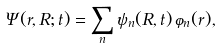Convert formula to latex. <formula><loc_0><loc_0><loc_500><loc_500>\Psi ( r , R ; t ) = \sum _ { n } \psi _ { n } ( R , t ) \, \varphi _ { n } ( r ) ,</formula> 